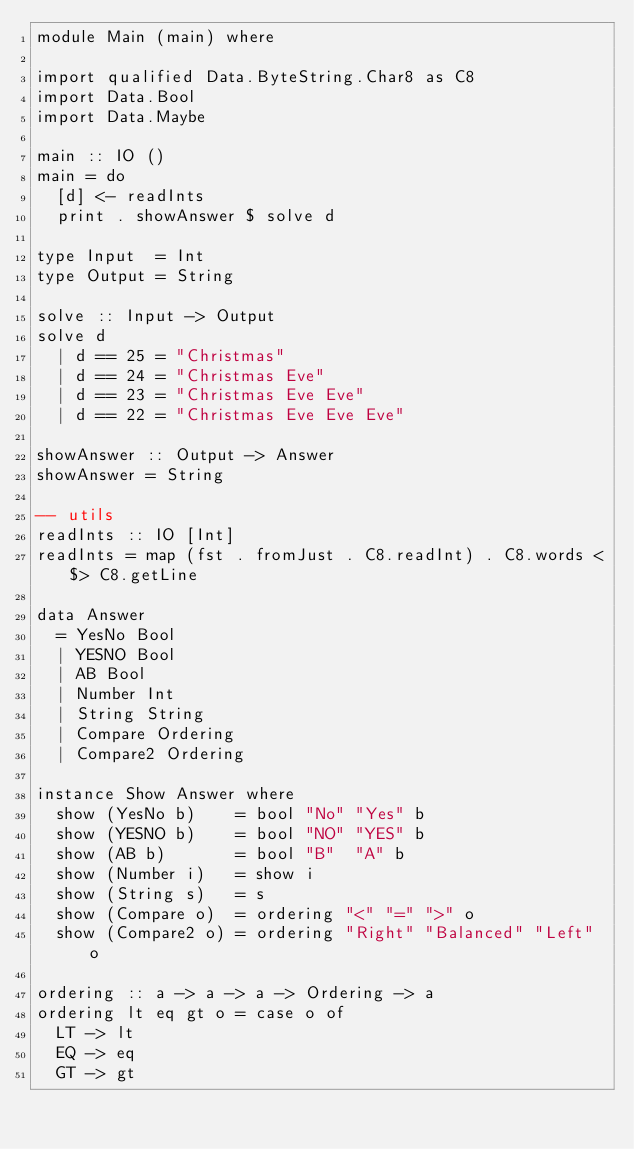<code> <loc_0><loc_0><loc_500><loc_500><_Haskell_>module Main (main) where

import qualified Data.ByteString.Char8 as C8
import Data.Bool
import Data.Maybe

main :: IO ()
main = do
  [d] <- readInts
  print . showAnswer $ solve d

type Input  = Int
type Output = String

solve :: Input -> Output
solve d
  | d == 25 = "Christmas"
  | d == 24 = "Christmas Eve"
  | d == 23 = "Christmas Eve Eve"
  | d == 22 = "Christmas Eve Eve Eve"

showAnswer :: Output -> Answer
showAnswer = String

-- utils
readInts :: IO [Int]
readInts = map (fst . fromJust . C8.readInt) . C8.words <$> C8.getLine

data Answer
  = YesNo Bool
  | YESNO Bool
  | AB Bool
  | Number Int
  | String String
  | Compare Ordering
  | Compare2 Ordering

instance Show Answer where
  show (YesNo b)    = bool "No" "Yes" b
  show (YESNO b)    = bool "NO" "YES" b
  show (AB b)       = bool "B"  "A" b
  show (Number i)   = show i
  show (String s)   = s
  show (Compare o)  = ordering "<" "=" ">" o
  show (Compare2 o) = ordering "Right" "Balanced" "Left" o

ordering :: a -> a -> a -> Ordering -> a
ordering lt eq gt o = case o of
  LT -> lt
  EQ -> eq
  GT -> gt</code> 